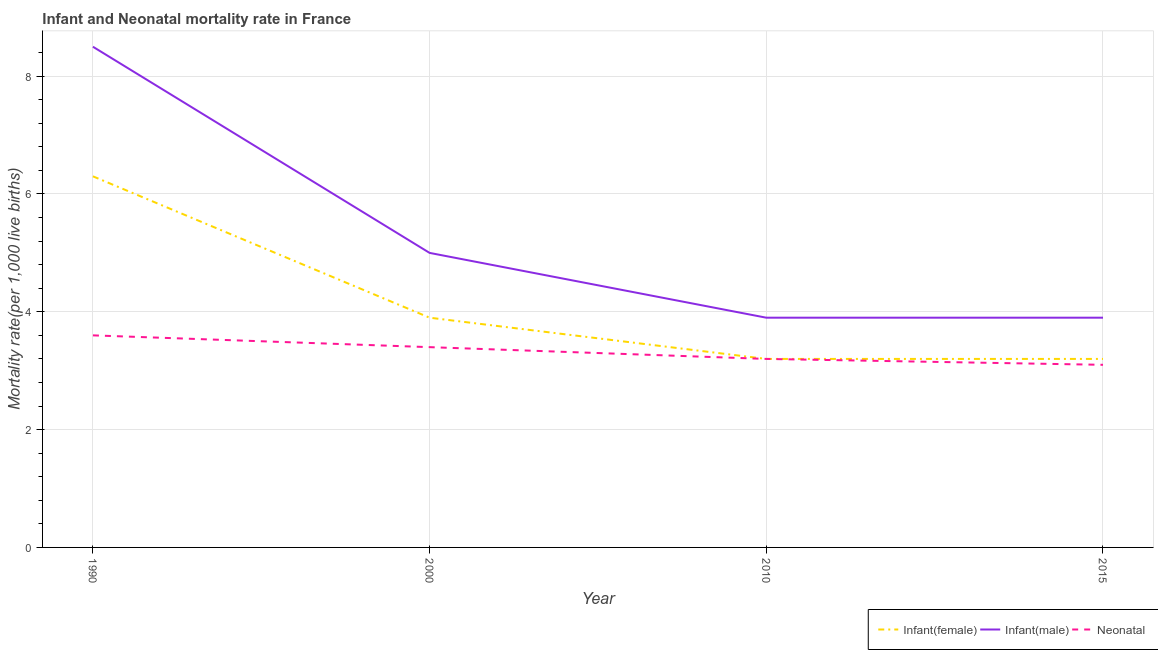How many different coloured lines are there?
Offer a terse response. 3. Across all years, what is the maximum infant mortality rate(female)?
Make the answer very short. 6.3. What is the total neonatal mortality rate in the graph?
Offer a very short reply. 13.3. What is the difference between the infant mortality rate(female) in 2010 and that in 2015?
Your answer should be very brief. 0. What is the difference between the infant mortality rate(male) in 2015 and the neonatal mortality rate in 2000?
Give a very brief answer. 0.5. What is the average neonatal mortality rate per year?
Ensure brevity in your answer.  3.32. What is the ratio of the infant mortality rate(male) in 2000 to that in 2015?
Keep it short and to the point. 1.28. Is the difference between the infant mortality rate(female) in 1990 and 2015 greater than the difference between the neonatal mortality rate in 1990 and 2015?
Offer a terse response. Yes. What is the difference between the highest and the second highest infant mortality rate(male)?
Provide a short and direct response. 3.5. What is the difference between the highest and the lowest infant mortality rate(female)?
Offer a terse response. 3.1. Is the sum of the infant mortality rate(male) in 1990 and 2015 greater than the maximum infant mortality rate(female) across all years?
Ensure brevity in your answer.  Yes. Does the infant mortality rate(male) monotonically increase over the years?
Your response must be concise. No. Is the infant mortality rate(female) strictly greater than the infant mortality rate(male) over the years?
Make the answer very short. No. What is the difference between two consecutive major ticks on the Y-axis?
Your answer should be compact. 2. Where does the legend appear in the graph?
Your answer should be compact. Bottom right. How many legend labels are there?
Ensure brevity in your answer.  3. How are the legend labels stacked?
Provide a short and direct response. Horizontal. What is the title of the graph?
Your answer should be very brief. Infant and Neonatal mortality rate in France. What is the label or title of the Y-axis?
Give a very brief answer. Mortality rate(per 1,0 live births). What is the Mortality rate(per 1,000 live births) of Neonatal  in 2000?
Offer a terse response. 3.4. What is the Mortality rate(per 1,000 live births) of Infant(female) in 2010?
Keep it short and to the point. 3.2. What is the Mortality rate(per 1,000 live births) of Neonatal  in 2015?
Offer a terse response. 3.1. Across all years, what is the maximum Mortality rate(per 1,000 live births) of Infant(male)?
Offer a terse response. 8.5. Across all years, what is the minimum Mortality rate(per 1,000 live births) of Infant(female)?
Give a very brief answer. 3.2. What is the total Mortality rate(per 1,000 live births) in Infant(female) in the graph?
Keep it short and to the point. 16.6. What is the total Mortality rate(per 1,000 live births) of Infant(male) in the graph?
Your response must be concise. 21.3. What is the difference between the Mortality rate(per 1,000 live births) in Infant(female) in 1990 and that in 2000?
Your answer should be very brief. 2.4. What is the difference between the Mortality rate(per 1,000 live births) in Infant(male) in 1990 and that in 2000?
Ensure brevity in your answer.  3.5. What is the difference between the Mortality rate(per 1,000 live births) of Neonatal  in 1990 and that in 2000?
Keep it short and to the point. 0.2. What is the difference between the Mortality rate(per 1,000 live births) of Infant(female) in 1990 and that in 2015?
Make the answer very short. 3.1. What is the difference between the Mortality rate(per 1,000 live births) of Infant(female) in 2000 and that in 2010?
Offer a very short reply. 0.7. What is the difference between the Mortality rate(per 1,000 live births) in Infant(male) in 2000 and that in 2010?
Make the answer very short. 1.1. What is the difference between the Mortality rate(per 1,000 live births) in Infant(female) in 2000 and that in 2015?
Offer a terse response. 0.7. What is the difference between the Mortality rate(per 1,000 live births) in Infant(male) in 2000 and that in 2015?
Your response must be concise. 1.1. What is the difference between the Mortality rate(per 1,000 live births) of Infant(male) in 2010 and that in 2015?
Keep it short and to the point. 0. What is the difference between the Mortality rate(per 1,000 live births) of Infant(female) in 1990 and the Mortality rate(per 1,000 live births) of Infant(male) in 2000?
Your response must be concise. 1.3. What is the difference between the Mortality rate(per 1,000 live births) in Infant(male) in 1990 and the Mortality rate(per 1,000 live births) in Neonatal  in 2000?
Offer a very short reply. 5.1. What is the difference between the Mortality rate(per 1,000 live births) in Infant(female) in 1990 and the Mortality rate(per 1,000 live births) in Infant(male) in 2010?
Keep it short and to the point. 2.4. What is the difference between the Mortality rate(per 1,000 live births) of Infant(female) in 2000 and the Mortality rate(per 1,000 live births) of Infant(male) in 2010?
Offer a very short reply. 0. What is the difference between the Mortality rate(per 1,000 live births) of Infant(female) in 2000 and the Mortality rate(per 1,000 live births) of Neonatal  in 2010?
Give a very brief answer. 0.7. What is the difference between the Mortality rate(per 1,000 live births) in Infant(male) in 2000 and the Mortality rate(per 1,000 live births) in Neonatal  in 2010?
Provide a succinct answer. 1.8. What is the difference between the Mortality rate(per 1,000 live births) in Infant(female) in 2000 and the Mortality rate(per 1,000 live births) in Infant(male) in 2015?
Ensure brevity in your answer.  0. What is the difference between the Mortality rate(per 1,000 live births) of Infant(male) in 2010 and the Mortality rate(per 1,000 live births) of Neonatal  in 2015?
Ensure brevity in your answer.  0.8. What is the average Mortality rate(per 1,000 live births) in Infant(female) per year?
Make the answer very short. 4.15. What is the average Mortality rate(per 1,000 live births) of Infant(male) per year?
Give a very brief answer. 5.33. What is the average Mortality rate(per 1,000 live births) in Neonatal  per year?
Your answer should be compact. 3.33. In the year 1990, what is the difference between the Mortality rate(per 1,000 live births) of Infant(female) and Mortality rate(per 1,000 live births) of Neonatal ?
Your response must be concise. 2.7. In the year 1990, what is the difference between the Mortality rate(per 1,000 live births) in Infant(male) and Mortality rate(per 1,000 live births) in Neonatal ?
Your response must be concise. 4.9. In the year 2000, what is the difference between the Mortality rate(per 1,000 live births) of Infant(female) and Mortality rate(per 1,000 live births) of Infant(male)?
Keep it short and to the point. -1.1. In the year 2000, what is the difference between the Mortality rate(per 1,000 live births) of Infant(female) and Mortality rate(per 1,000 live births) of Neonatal ?
Offer a terse response. 0.5. In the year 2000, what is the difference between the Mortality rate(per 1,000 live births) of Infant(male) and Mortality rate(per 1,000 live births) of Neonatal ?
Your response must be concise. 1.6. In the year 2010, what is the difference between the Mortality rate(per 1,000 live births) of Infant(female) and Mortality rate(per 1,000 live births) of Infant(male)?
Keep it short and to the point. -0.7. In the year 2015, what is the difference between the Mortality rate(per 1,000 live births) of Infant(female) and Mortality rate(per 1,000 live births) of Infant(male)?
Give a very brief answer. -0.7. In the year 2015, what is the difference between the Mortality rate(per 1,000 live births) of Infant(female) and Mortality rate(per 1,000 live births) of Neonatal ?
Provide a succinct answer. 0.1. In the year 2015, what is the difference between the Mortality rate(per 1,000 live births) in Infant(male) and Mortality rate(per 1,000 live births) in Neonatal ?
Provide a succinct answer. 0.8. What is the ratio of the Mortality rate(per 1,000 live births) of Infant(female) in 1990 to that in 2000?
Your response must be concise. 1.62. What is the ratio of the Mortality rate(per 1,000 live births) in Infant(male) in 1990 to that in 2000?
Provide a short and direct response. 1.7. What is the ratio of the Mortality rate(per 1,000 live births) of Neonatal  in 1990 to that in 2000?
Make the answer very short. 1.06. What is the ratio of the Mortality rate(per 1,000 live births) in Infant(female) in 1990 to that in 2010?
Give a very brief answer. 1.97. What is the ratio of the Mortality rate(per 1,000 live births) in Infant(male) in 1990 to that in 2010?
Keep it short and to the point. 2.18. What is the ratio of the Mortality rate(per 1,000 live births) in Infant(female) in 1990 to that in 2015?
Keep it short and to the point. 1.97. What is the ratio of the Mortality rate(per 1,000 live births) in Infant(male) in 1990 to that in 2015?
Provide a short and direct response. 2.18. What is the ratio of the Mortality rate(per 1,000 live births) in Neonatal  in 1990 to that in 2015?
Your answer should be very brief. 1.16. What is the ratio of the Mortality rate(per 1,000 live births) of Infant(female) in 2000 to that in 2010?
Keep it short and to the point. 1.22. What is the ratio of the Mortality rate(per 1,000 live births) in Infant(male) in 2000 to that in 2010?
Offer a very short reply. 1.28. What is the ratio of the Mortality rate(per 1,000 live births) of Neonatal  in 2000 to that in 2010?
Keep it short and to the point. 1.06. What is the ratio of the Mortality rate(per 1,000 live births) in Infant(female) in 2000 to that in 2015?
Offer a terse response. 1.22. What is the ratio of the Mortality rate(per 1,000 live births) in Infant(male) in 2000 to that in 2015?
Your response must be concise. 1.28. What is the ratio of the Mortality rate(per 1,000 live births) in Neonatal  in 2000 to that in 2015?
Make the answer very short. 1.1. What is the ratio of the Mortality rate(per 1,000 live births) in Neonatal  in 2010 to that in 2015?
Your response must be concise. 1.03. What is the difference between the highest and the lowest Mortality rate(per 1,000 live births) of Infant(male)?
Offer a very short reply. 4.6. 